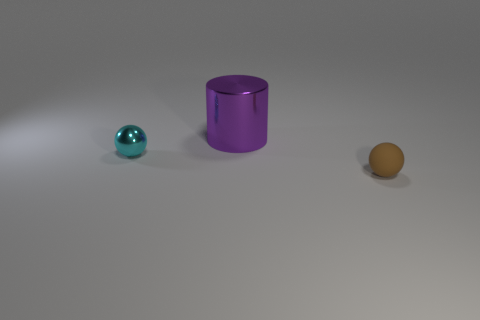Add 2 balls. How many objects exist? 5 Subtract all balls. How many objects are left? 1 Subtract 0 gray spheres. How many objects are left? 3 Subtract all shiny balls. Subtract all brown spheres. How many objects are left? 1 Add 3 brown matte objects. How many brown matte objects are left? 4 Add 3 cyan spheres. How many cyan spheres exist? 4 